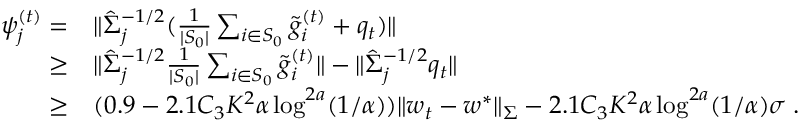Convert formula to latex. <formula><loc_0><loc_0><loc_500><loc_500>\begin{array} { r l } { \psi _ { j } ^ { ( t ) } = } & { \| \hat { \Sigma } _ { j } ^ { - 1 / 2 } ( \frac { 1 } { | S _ { 0 } | } \sum _ { i \in S _ { 0 } } \tilde { g } _ { i } ^ { ( t ) } + q _ { t } ) \| } \\ { \geq } & { \| \hat { \Sigma } _ { j } ^ { - 1 / 2 } \frac { 1 } { | S _ { 0 } | } \sum _ { i \in S _ { 0 } } \tilde { g } _ { i } ^ { ( t ) } \| - \| \hat { \Sigma } _ { j } ^ { - 1 / 2 } q _ { t } \| } \\ { \geq } & { ( 0 . 9 - 2 . 1 C _ { 3 } K ^ { 2 } \alpha \log ^ { 2 a } ( 1 / \alpha ) ) \| w _ { t } - w ^ { * } \| _ { \Sigma } - 2 . 1 C _ { 3 } K ^ { 2 } \alpha \log ^ { 2 a } ( 1 / \alpha ) \sigma \, . } \end{array}</formula> 